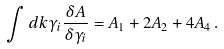<formula> <loc_0><loc_0><loc_500><loc_500>\int d k \gamma _ { i } \frac { \delta A } { \delta \gamma _ { i } } = A _ { 1 } + 2 A _ { 2 } + 4 A _ { 4 } \, .</formula> 